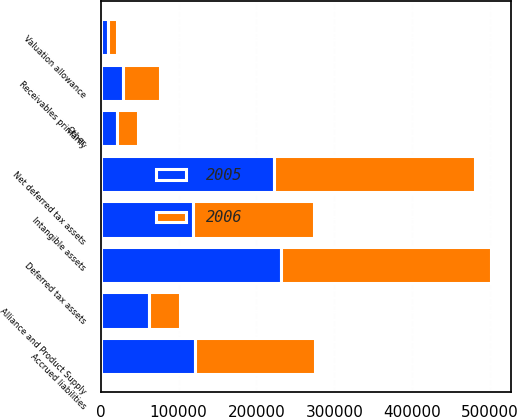<chart> <loc_0><loc_0><loc_500><loc_500><stacked_bar_chart><ecel><fcel>Receivables primarily<fcel>Alliance and Product Supply<fcel>Accrued liabilities<fcel>Other<fcel>Deferred tax assets<fcel>Valuation allowance<fcel>Net deferred tax assets<fcel>Intangible assets<nl><fcel>2006<fcel>47054<fcel>40947<fcel>154169<fcel>27638<fcel>269808<fcel>10656<fcel>259152<fcel>155762<nl><fcel>2005<fcel>28805<fcel>61480<fcel>121404<fcel>20287<fcel>231976<fcel>9898<fcel>222078<fcel>118240<nl></chart> 